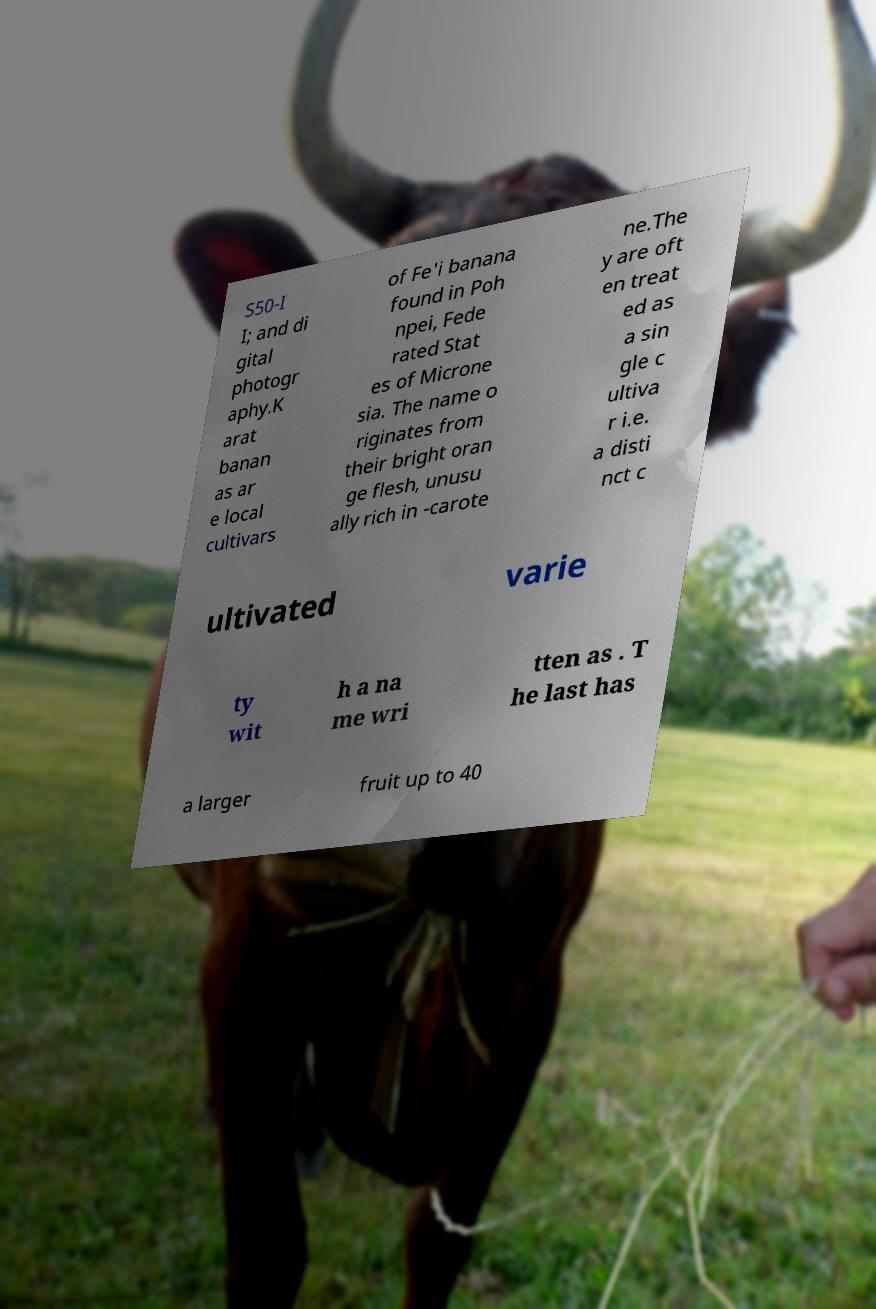Can you read and provide the text displayed in the image?This photo seems to have some interesting text. Can you extract and type it out for me? S50-I I; and di gital photogr aphy.K arat banan as ar e local cultivars of Fe'i banana found in Poh npei, Fede rated Stat es of Microne sia. The name o riginates from their bright oran ge flesh, unusu ally rich in -carote ne.The y are oft en treat ed as a sin gle c ultiva r i.e. a disti nct c ultivated varie ty wit h a na me wri tten as . T he last has a larger fruit up to 40 